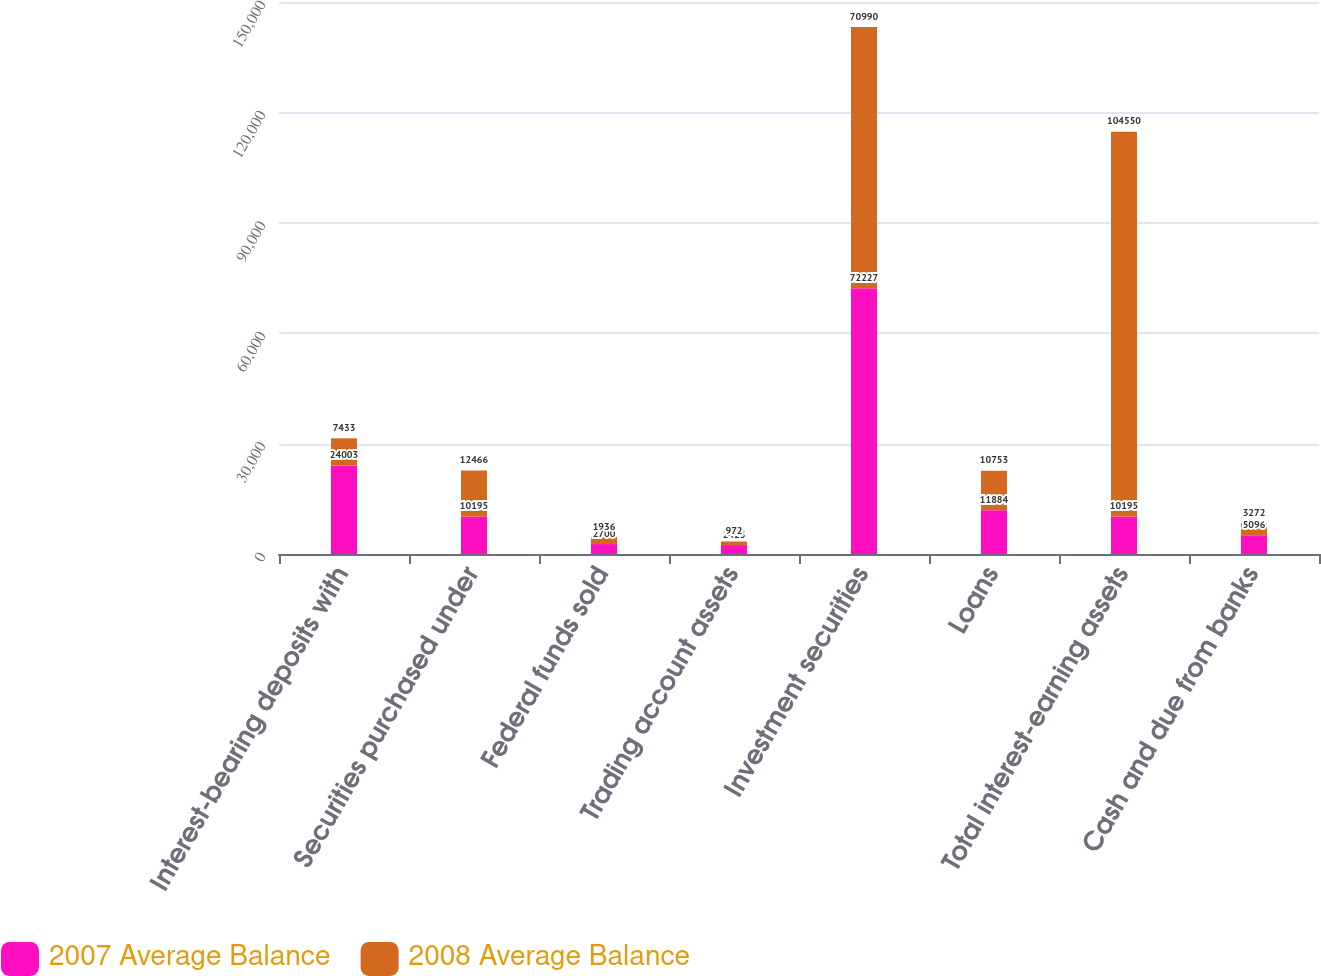<chart> <loc_0><loc_0><loc_500><loc_500><stacked_bar_chart><ecel><fcel>Interest-bearing deposits with<fcel>Securities purchased under<fcel>Federal funds sold<fcel>Trading account assets<fcel>Investment securities<fcel>Loans<fcel>Total interest-earning assets<fcel>Cash and due from banks<nl><fcel>2007 Average Balance<fcel>24003<fcel>10195<fcel>2700<fcel>2423<fcel>72227<fcel>11884<fcel>10195<fcel>5096<nl><fcel>2008 Average Balance<fcel>7433<fcel>12466<fcel>1936<fcel>972<fcel>70990<fcel>10753<fcel>104550<fcel>3272<nl></chart> 